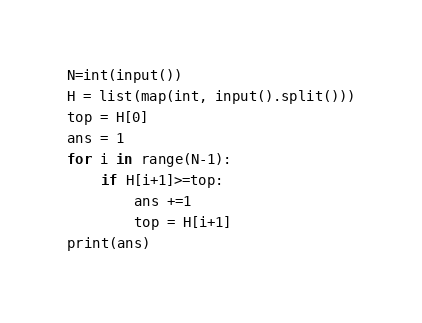<code> <loc_0><loc_0><loc_500><loc_500><_Python_>N=int(input())
H = list(map(int, input().split()))
top = H[0]
ans = 1
for i in range(N-1):
    if H[i+1]>=top:
        ans +=1
        top = H[i+1]
print(ans)</code> 